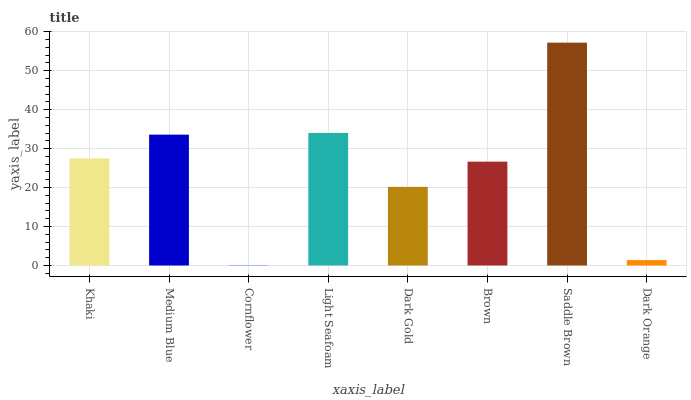Is Cornflower the minimum?
Answer yes or no. Yes. Is Saddle Brown the maximum?
Answer yes or no. Yes. Is Medium Blue the minimum?
Answer yes or no. No. Is Medium Blue the maximum?
Answer yes or no. No. Is Medium Blue greater than Khaki?
Answer yes or no. Yes. Is Khaki less than Medium Blue?
Answer yes or no. Yes. Is Khaki greater than Medium Blue?
Answer yes or no. No. Is Medium Blue less than Khaki?
Answer yes or no. No. Is Khaki the high median?
Answer yes or no. Yes. Is Brown the low median?
Answer yes or no. Yes. Is Cornflower the high median?
Answer yes or no. No. Is Dark Orange the low median?
Answer yes or no. No. 